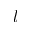<formula> <loc_0><loc_0><loc_500><loc_500>l</formula> 